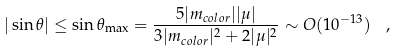<formula> <loc_0><loc_0><loc_500><loc_500>| \sin \theta | \leq \sin \theta _ { \max } = \frac { 5 | m _ { c o l o r } | | \mu | } { 3 | m _ { c o l o r } | ^ { 2 } + 2 | \mu | ^ { 2 } } \sim O ( 1 0 ^ { - 1 3 } ) \ \ ,</formula> 